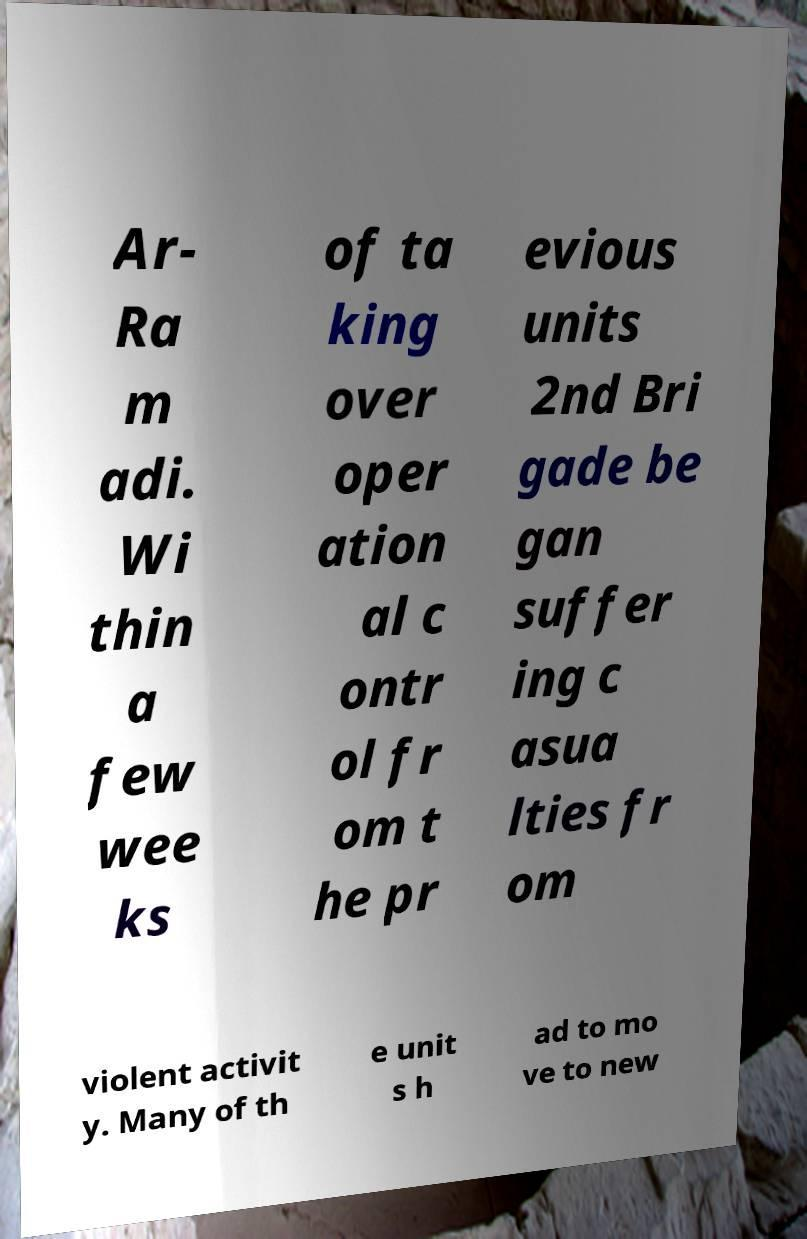I need the written content from this picture converted into text. Can you do that? Ar- Ra m adi. Wi thin a few wee ks of ta king over oper ation al c ontr ol fr om t he pr evious units 2nd Bri gade be gan suffer ing c asua lties fr om violent activit y. Many of th e unit s h ad to mo ve to new 